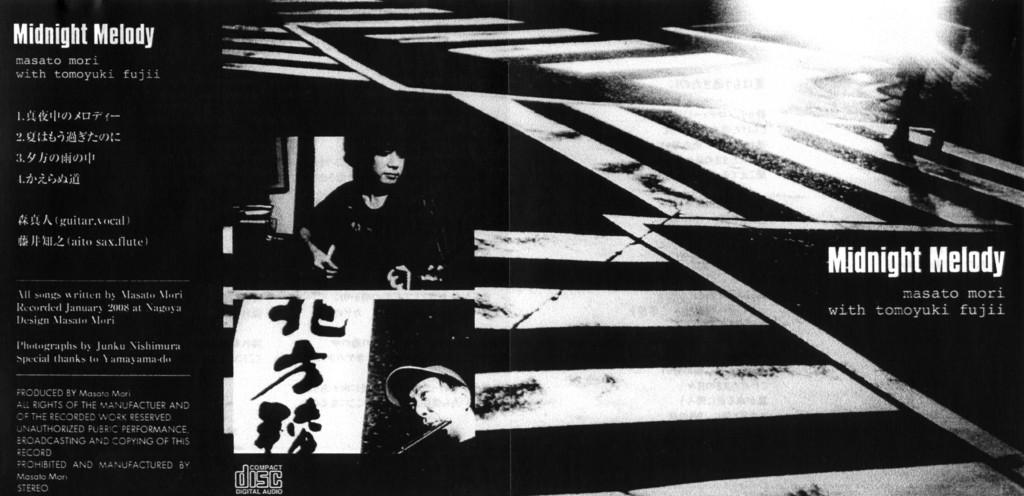<image>
Describe the image concisely. a poster for something called Midnight Melody with Tomoyuki Fujii 